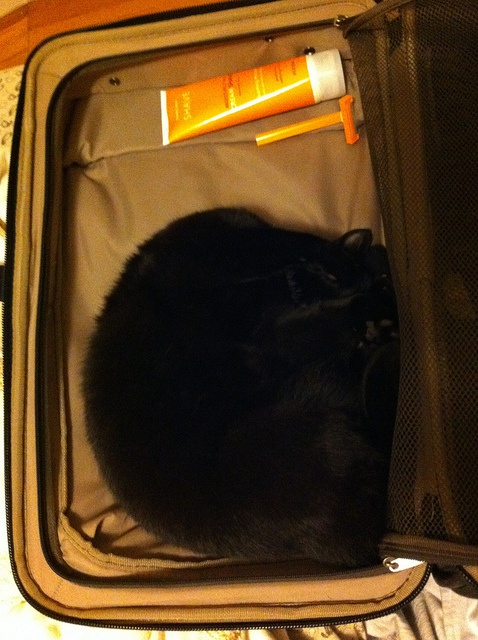Describe the objects in this image and their specific colors. I can see suitcase in black, olive, orange, and maroon tones and cat in orange, black, maroon, and olive tones in this image. 